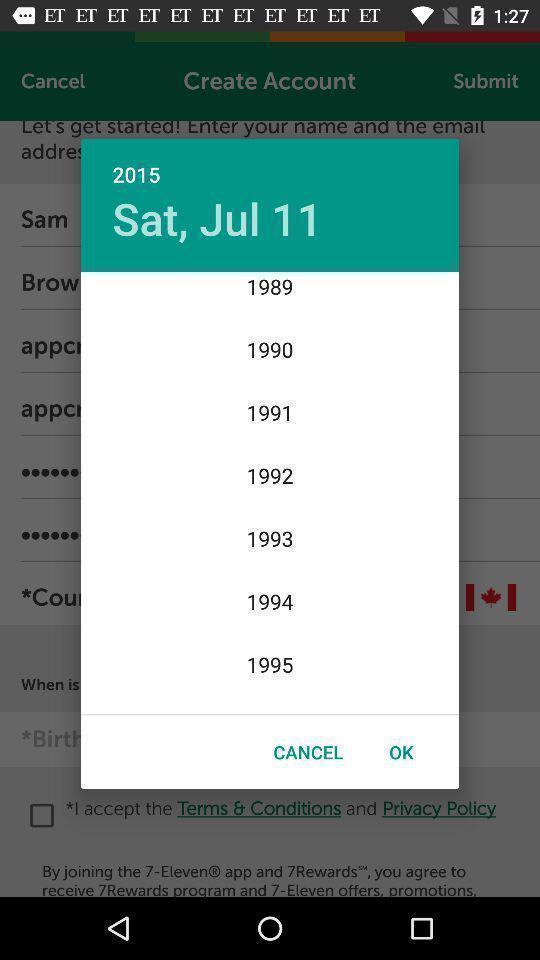What details can you identify in this image? Pop-up showing to select date. 